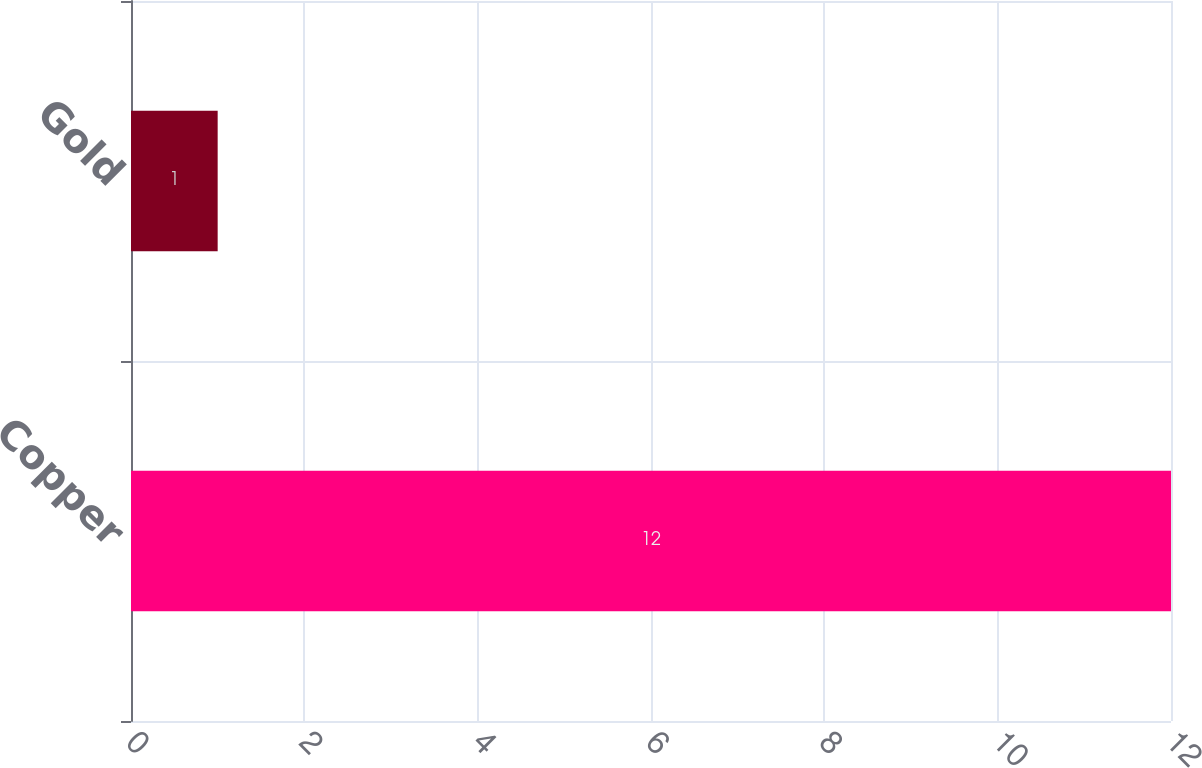<chart> <loc_0><loc_0><loc_500><loc_500><bar_chart><fcel>Copper<fcel>Gold<nl><fcel>12<fcel>1<nl></chart> 